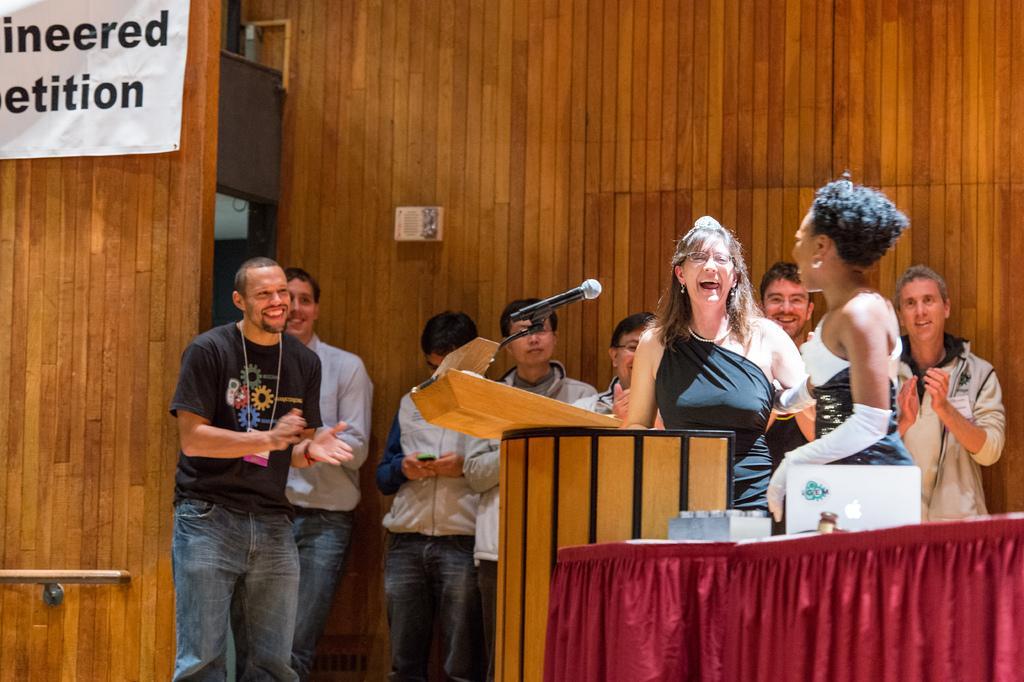Please provide a concise description of this image. Here we can see group of people. There is a mike, podium, table, and a cloth. In the background we can see a wall and a banner. 